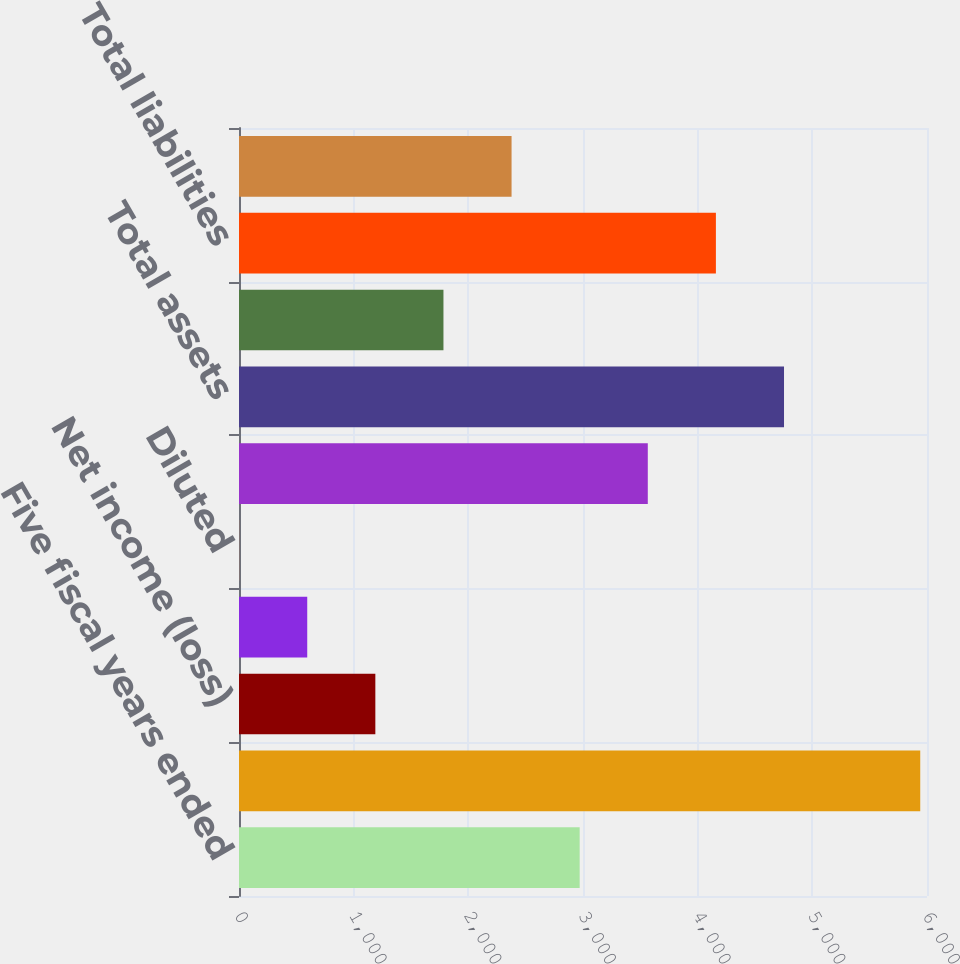Convert chart. <chart><loc_0><loc_0><loc_500><loc_500><bar_chart><fcel>Five fiscal years ended<fcel>Net sales<fcel>Net income (loss)<fcel>Basic<fcel>Diluted<fcel>Cash cash equivalents and<fcel>Total assets<fcel>Long-term debt<fcel>Total liabilities<fcel>Shareholders' equity<nl><fcel>2971.03<fcel>5941<fcel>1189.03<fcel>595.04<fcel>1.05<fcel>3565.03<fcel>4753.02<fcel>1783.03<fcel>4159.03<fcel>2377.03<nl></chart> 